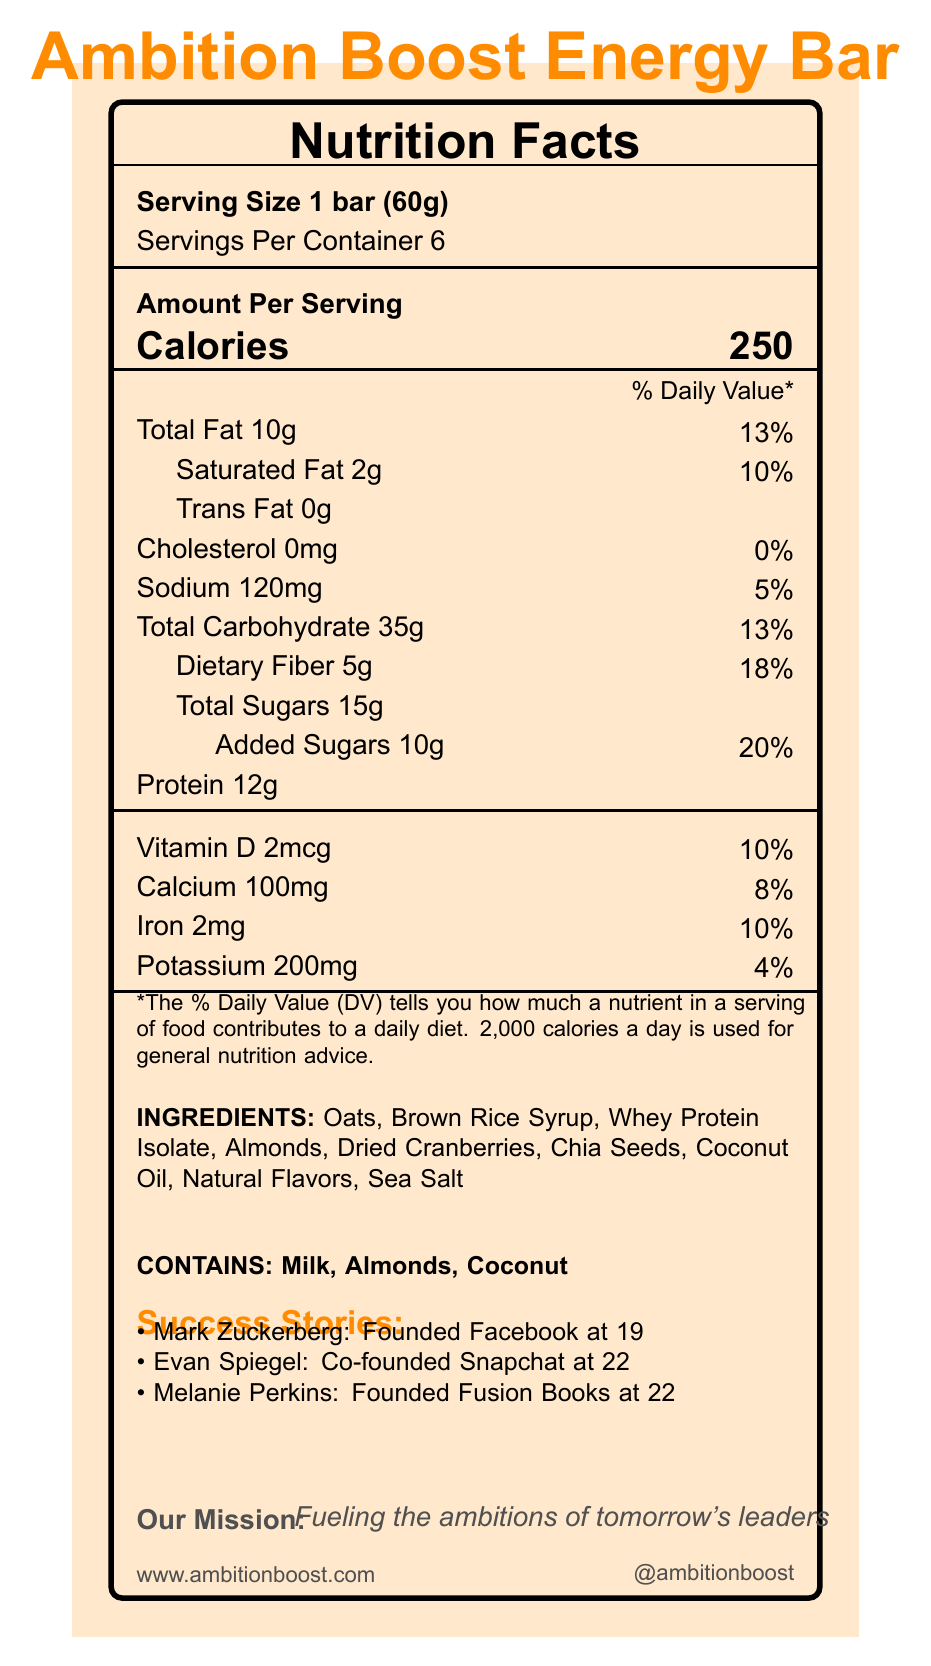what is the serving size of the Ambition Boost Energy Bar? The serving size is clearly listed as "1 bar (60g)" in the document.
Answer: 1 bar (60g) how many servings are there per container? The document states "Servings Per Container 6."
Answer: 6 what is the amount of total fat per serving? The document lists "Total Fat 10g" under the nutrition facts section.
Answer: 10g how much protein does one energy bar contain? The nutrition facts section states that each bar contains "Protein 12g."
Answer: 12g what ingredients are in the Ambition Boost Energy Bar? The ingredients list in the document includes these items.
Answer: Oats, Brown Rice Syrup, Whey Protein Isolate, Almonds, Dried Cranberries, Chia Seeds, Coconut Oil, Natural Flavors, Sea Salt who founded Fusion Books (which later evolved into Canva)? Melanie Perkins is credited with founding Fusion Books, which later evolved into Canva, according to the success stories section.
Answer: Melanie Perkins what is the percentage of daily value for added sugars? The document lists "Added Sugars 10g" with a "% Daily Value" of "20%" next to it.
Answer: 20% how much dietary fiber is in one serving of the energy bar? The dietary fiber content is listed as "5g" per serving in the nutrition facts.
Answer: 5g which of these vitamins or minerals is not mentioned in the document? A. Vitamin D B. Calcium C. Vitamin C D. Iron The document lists Vitamin D, Calcium, and Iron, but does not mention Vitamin C.
Answer: C how many calories are in one serving of the Ambition Boost Energy Bar? The document states that each serving contains "Calories 250".
Answer: 250 which success story involves the founder of Facebook? A. Evan Spiegel B. Mark Zuckerberg C. Melanie Perkins Mark Zuckerberg is listed in the success stories section as the founder of Facebook.
Answer: B is there any cholesterol in the Ambition Boost Energy Bar? The nutrition facts section lists "Cholesterol 0mg," indicating there is no cholesterol in the bar.
Answer: No do the energy bars contain any milk? The allergens section mentions "Contains: Milk, Almonds, Coconut," confirming that milk is an ingredient.
Answer: Yes what is the brand’s mission? The document states that the brand's mission is "Fueling the ambitions of tomorrow's leaders."
Answer: Fueling the ambitions of tomorrow's leaders summarize the document The document comprehensively covers the nutritional facts, ingredients, success stories, and motivational aspects related to the Ambition Boost Energy Bar.
Answer: The document provides detailed nutritional information about the Ambition Boost Energy Bar, including serving size, calorie content, and nutrient breakdown per serving. It lists the ingredients and allergens and features success stories of young entrepreneurs like Mark Zuckerberg, Evan Spiegel, and Melanie Perkins. Motivational quotes, entrepreneurial tips, and the brand's mission are also highlighted, accompanied by social media handles and the brand's website URL. does the document indicate how the ingredients are sourced? The document lists the ingredients but does not provide details regarding how they are sourced.
Answer: Not enough information 